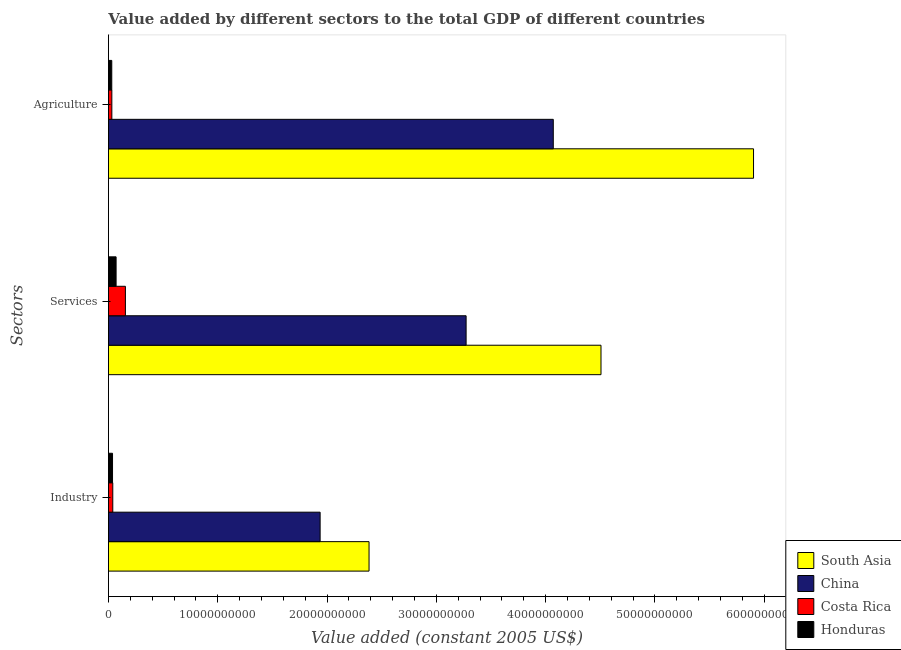How many different coloured bars are there?
Ensure brevity in your answer.  4. How many groups of bars are there?
Ensure brevity in your answer.  3. Are the number of bars on each tick of the Y-axis equal?
Offer a very short reply. Yes. How many bars are there on the 1st tick from the top?
Offer a terse response. 4. How many bars are there on the 1st tick from the bottom?
Make the answer very short. 4. What is the label of the 2nd group of bars from the top?
Give a very brief answer. Services. What is the value added by agricultural sector in Honduras?
Offer a very short reply. 3.05e+08. Across all countries, what is the maximum value added by industrial sector?
Ensure brevity in your answer.  2.38e+1. Across all countries, what is the minimum value added by agricultural sector?
Your answer should be compact. 3.05e+08. In which country was the value added by industrial sector minimum?
Your response must be concise. Honduras. What is the total value added by services in the graph?
Keep it short and to the point. 8.00e+1. What is the difference between the value added by services in China and that in Costa Rica?
Make the answer very short. 3.12e+1. What is the difference between the value added by services in South Asia and the value added by industrial sector in Costa Rica?
Your answer should be compact. 4.47e+1. What is the average value added by services per country?
Offer a very short reply. 2.00e+1. What is the difference between the value added by services and value added by agricultural sector in South Asia?
Keep it short and to the point. -1.40e+1. What is the ratio of the value added by services in Honduras to that in Costa Rica?
Offer a terse response. 0.45. What is the difference between the highest and the second highest value added by industrial sector?
Provide a succinct answer. 4.47e+09. What is the difference between the highest and the lowest value added by services?
Offer a very short reply. 4.44e+1. In how many countries, is the value added by industrial sector greater than the average value added by industrial sector taken over all countries?
Your answer should be compact. 2. What does the 1st bar from the top in Services represents?
Make the answer very short. Honduras. What does the 2nd bar from the bottom in Industry represents?
Your response must be concise. China. Is it the case that in every country, the sum of the value added by industrial sector and value added by services is greater than the value added by agricultural sector?
Your response must be concise. Yes. How many bars are there?
Offer a very short reply. 12. How many countries are there in the graph?
Your response must be concise. 4. How are the legend labels stacked?
Ensure brevity in your answer.  Vertical. What is the title of the graph?
Your response must be concise. Value added by different sectors to the total GDP of different countries. What is the label or title of the X-axis?
Give a very brief answer. Value added (constant 2005 US$). What is the label or title of the Y-axis?
Give a very brief answer. Sectors. What is the Value added (constant 2005 US$) of South Asia in Industry?
Your response must be concise. 2.38e+1. What is the Value added (constant 2005 US$) of China in Industry?
Offer a very short reply. 1.94e+1. What is the Value added (constant 2005 US$) in Costa Rica in Industry?
Offer a terse response. 3.98e+08. What is the Value added (constant 2005 US$) of Honduras in Industry?
Offer a terse response. 3.75e+08. What is the Value added (constant 2005 US$) in South Asia in Services?
Provide a short and direct response. 4.51e+1. What is the Value added (constant 2005 US$) in China in Services?
Offer a very short reply. 3.27e+1. What is the Value added (constant 2005 US$) in Costa Rica in Services?
Give a very brief answer. 1.55e+09. What is the Value added (constant 2005 US$) of Honduras in Services?
Provide a succinct answer. 7.01e+08. What is the Value added (constant 2005 US$) of South Asia in Agriculture?
Keep it short and to the point. 5.90e+1. What is the Value added (constant 2005 US$) of China in Agriculture?
Offer a very short reply. 4.07e+1. What is the Value added (constant 2005 US$) in Costa Rica in Agriculture?
Make the answer very short. 3.13e+08. What is the Value added (constant 2005 US$) of Honduras in Agriculture?
Make the answer very short. 3.05e+08. Across all Sectors, what is the maximum Value added (constant 2005 US$) in South Asia?
Offer a terse response. 5.90e+1. Across all Sectors, what is the maximum Value added (constant 2005 US$) in China?
Make the answer very short. 4.07e+1. Across all Sectors, what is the maximum Value added (constant 2005 US$) of Costa Rica?
Offer a terse response. 1.55e+09. Across all Sectors, what is the maximum Value added (constant 2005 US$) in Honduras?
Your answer should be compact. 7.01e+08. Across all Sectors, what is the minimum Value added (constant 2005 US$) of South Asia?
Ensure brevity in your answer.  2.38e+1. Across all Sectors, what is the minimum Value added (constant 2005 US$) in China?
Your response must be concise. 1.94e+1. Across all Sectors, what is the minimum Value added (constant 2005 US$) in Costa Rica?
Ensure brevity in your answer.  3.13e+08. Across all Sectors, what is the minimum Value added (constant 2005 US$) in Honduras?
Provide a short and direct response. 3.05e+08. What is the total Value added (constant 2005 US$) of South Asia in the graph?
Make the answer very short. 1.28e+11. What is the total Value added (constant 2005 US$) in China in the graph?
Your answer should be compact. 9.28e+1. What is the total Value added (constant 2005 US$) in Costa Rica in the graph?
Your answer should be very brief. 2.26e+09. What is the total Value added (constant 2005 US$) in Honduras in the graph?
Make the answer very short. 1.38e+09. What is the difference between the Value added (constant 2005 US$) in South Asia in Industry and that in Services?
Offer a terse response. -2.12e+1. What is the difference between the Value added (constant 2005 US$) of China in Industry and that in Services?
Your answer should be compact. -1.34e+1. What is the difference between the Value added (constant 2005 US$) in Costa Rica in Industry and that in Services?
Offer a terse response. -1.15e+09. What is the difference between the Value added (constant 2005 US$) of Honduras in Industry and that in Services?
Provide a succinct answer. -3.26e+08. What is the difference between the Value added (constant 2005 US$) of South Asia in Industry and that in Agriculture?
Your answer should be compact. -3.52e+1. What is the difference between the Value added (constant 2005 US$) of China in Industry and that in Agriculture?
Provide a short and direct response. -2.13e+1. What is the difference between the Value added (constant 2005 US$) of Costa Rica in Industry and that in Agriculture?
Your response must be concise. 8.48e+07. What is the difference between the Value added (constant 2005 US$) of Honduras in Industry and that in Agriculture?
Give a very brief answer. 6.98e+07. What is the difference between the Value added (constant 2005 US$) in South Asia in Services and that in Agriculture?
Your answer should be very brief. -1.40e+1. What is the difference between the Value added (constant 2005 US$) of China in Services and that in Agriculture?
Provide a short and direct response. -7.98e+09. What is the difference between the Value added (constant 2005 US$) of Costa Rica in Services and that in Agriculture?
Offer a terse response. 1.24e+09. What is the difference between the Value added (constant 2005 US$) of Honduras in Services and that in Agriculture?
Your answer should be compact. 3.96e+08. What is the difference between the Value added (constant 2005 US$) of South Asia in Industry and the Value added (constant 2005 US$) of China in Services?
Keep it short and to the point. -8.88e+09. What is the difference between the Value added (constant 2005 US$) in South Asia in Industry and the Value added (constant 2005 US$) in Costa Rica in Services?
Your response must be concise. 2.23e+1. What is the difference between the Value added (constant 2005 US$) of South Asia in Industry and the Value added (constant 2005 US$) of Honduras in Services?
Ensure brevity in your answer.  2.31e+1. What is the difference between the Value added (constant 2005 US$) of China in Industry and the Value added (constant 2005 US$) of Costa Rica in Services?
Ensure brevity in your answer.  1.78e+1. What is the difference between the Value added (constant 2005 US$) of China in Industry and the Value added (constant 2005 US$) of Honduras in Services?
Give a very brief answer. 1.87e+1. What is the difference between the Value added (constant 2005 US$) in Costa Rica in Industry and the Value added (constant 2005 US$) in Honduras in Services?
Provide a short and direct response. -3.03e+08. What is the difference between the Value added (constant 2005 US$) of South Asia in Industry and the Value added (constant 2005 US$) of China in Agriculture?
Offer a very short reply. -1.69e+1. What is the difference between the Value added (constant 2005 US$) of South Asia in Industry and the Value added (constant 2005 US$) of Costa Rica in Agriculture?
Your answer should be very brief. 2.35e+1. What is the difference between the Value added (constant 2005 US$) of South Asia in Industry and the Value added (constant 2005 US$) of Honduras in Agriculture?
Your response must be concise. 2.35e+1. What is the difference between the Value added (constant 2005 US$) in China in Industry and the Value added (constant 2005 US$) in Costa Rica in Agriculture?
Your answer should be very brief. 1.91e+1. What is the difference between the Value added (constant 2005 US$) in China in Industry and the Value added (constant 2005 US$) in Honduras in Agriculture?
Your answer should be very brief. 1.91e+1. What is the difference between the Value added (constant 2005 US$) of Costa Rica in Industry and the Value added (constant 2005 US$) of Honduras in Agriculture?
Offer a terse response. 9.24e+07. What is the difference between the Value added (constant 2005 US$) in South Asia in Services and the Value added (constant 2005 US$) in China in Agriculture?
Offer a terse response. 4.37e+09. What is the difference between the Value added (constant 2005 US$) in South Asia in Services and the Value added (constant 2005 US$) in Costa Rica in Agriculture?
Provide a short and direct response. 4.48e+1. What is the difference between the Value added (constant 2005 US$) of South Asia in Services and the Value added (constant 2005 US$) of Honduras in Agriculture?
Provide a short and direct response. 4.48e+1. What is the difference between the Value added (constant 2005 US$) of China in Services and the Value added (constant 2005 US$) of Costa Rica in Agriculture?
Ensure brevity in your answer.  3.24e+1. What is the difference between the Value added (constant 2005 US$) of China in Services and the Value added (constant 2005 US$) of Honduras in Agriculture?
Ensure brevity in your answer.  3.24e+1. What is the difference between the Value added (constant 2005 US$) in Costa Rica in Services and the Value added (constant 2005 US$) in Honduras in Agriculture?
Give a very brief answer. 1.25e+09. What is the average Value added (constant 2005 US$) of South Asia per Sectors?
Provide a succinct answer. 4.26e+1. What is the average Value added (constant 2005 US$) in China per Sectors?
Keep it short and to the point. 3.09e+1. What is the average Value added (constant 2005 US$) of Costa Rica per Sectors?
Offer a terse response. 7.54e+08. What is the average Value added (constant 2005 US$) in Honduras per Sectors?
Offer a very short reply. 4.61e+08. What is the difference between the Value added (constant 2005 US$) of South Asia and Value added (constant 2005 US$) of China in Industry?
Ensure brevity in your answer.  4.47e+09. What is the difference between the Value added (constant 2005 US$) in South Asia and Value added (constant 2005 US$) in Costa Rica in Industry?
Provide a succinct answer. 2.34e+1. What is the difference between the Value added (constant 2005 US$) in South Asia and Value added (constant 2005 US$) in Honduras in Industry?
Ensure brevity in your answer.  2.35e+1. What is the difference between the Value added (constant 2005 US$) in China and Value added (constant 2005 US$) in Costa Rica in Industry?
Offer a terse response. 1.90e+1. What is the difference between the Value added (constant 2005 US$) of China and Value added (constant 2005 US$) of Honduras in Industry?
Make the answer very short. 1.90e+1. What is the difference between the Value added (constant 2005 US$) of Costa Rica and Value added (constant 2005 US$) of Honduras in Industry?
Make the answer very short. 2.26e+07. What is the difference between the Value added (constant 2005 US$) of South Asia and Value added (constant 2005 US$) of China in Services?
Your answer should be compact. 1.23e+1. What is the difference between the Value added (constant 2005 US$) in South Asia and Value added (constant 2005 US$) in Costa Rica in Services?
Provide a succinct answer. 4.35e+1. What is the difference between the Value added (constant 2005 US$) of South Asia and Value added (constant 2005 US$) of Honduras in Services?
Provide a short and direct response. 4.44e+1. What is the difference between the Value added (constant 2005 US$) in China and Value added (constant 2005 US$) in Costa Rica in Services?
Provide a short and direct response. 3.12e+1. What is the difference between the Value added (constant 2005 US$) of China and Value added (constant 2005 US$) of Honduras in Services?
Keep it short and to the point. 3.20e+1. What is the difference between the Value added (constant 2005 US$) of Costa Rica and Value added (constant 2005 US$) of Honduras in Services?
Your response must be concise. 8.51e+08. What is the difference between the Value added (constant 2005 US$) in South Asia and Value added (constant 2005 US$) in China in Agriculture?
Make the answer very short. 1.83e+1. What is the difference between the Value added (constant 2005 US$) of South Asia and Value added (constant 2005 US$) of Costa Rica in Agriculture?
Ensure brevity in your answer.  5.87e+1. What is the difference between the Value added (constant 2005 US$) of South Asia and Value added (constant 2005 US$) of Honduras in Agriculture?
Your answer should be very brief. 5.87e+1. What is the difference between the Value added (constant 2005 US$) of China and Value added (constant 2005 US$) of Costa Rica in Agriculture?
Provide a succinct answer. 4.04e+1. What is the difference between the Value added (constant 2005 US$) of China and Value added (constant 2005 US$) of Honduras in Agriculture?
Give a very brief answer. 4.04e+1. What is the difference between the Value added (constant 2005 US$) in Costa Rica and Value added (constant 2005 US$) in Honduras in Agriculture?
Ensure brevity in your answer.  7.61e+06. What is the ratio of the Value added (constant 2005 US$) in South Asia in Industry to that in Services?
Your response must be concise. 0.53. What is the ratio of the Value added (constant 2005 US$) in China in Industry to that in Services?
Ensure brevity in your answer.  0.59. What is the ratio of the Value added (constant 2005 US$) of Costa Rica in Industry to that in Services?
Offer a very short reply. 0.26. What is the ratio of the Value added (constant 2005 US$) of Honduras in Industry to that in Services?
Provide a short and direct response. 0.54. What is the ratio of the Value added (constant 2005 US$) in South Asia in Industry to that in Agriculture?
Provide a short and direct response. 0.4. What is the ratio of the Value added (constant 2005 US$) of China in Industry to that in Agriculture?
Your answer should be very brief. 0.48. What is the ratio of the Value added (constant 2005 US$) of Costa Rica in Industry to that in Agriculture?
Provide a succinct answer. 1.27. What is the ratio of the Value added (constant 2005 US$) of Honduras in Industry to that in Agriculture?
Give a very brief answer. 1.23. What is the ratio of the Value added (constant 2005 US$) of South Asia in Services to that in Agriculture?
Give a very brief answer. 0.76. What is the ratio of the Value added (constant 2005 US$) of China in Services to that in Agriculture?
Make the answer very short. 0.8. What is the ratio of the Value added (constant 2005 US$) of Costa Rica in Services to that in Agriculture?
Provide a short and direct response. 4.96. What is the ratio of the Value added (constant 2005 US$) of Honduras in Services to that in Agriculture?
Offer a very short reply. 2.3. What is the difference between the highest and the second highest Value added (constant 2005 US$) in South Asia?
Provide a short and direct response. 1.40e+1. What is the difference between the highest and the second highest Value added (constant 2005 US$) in China?
Keep it short and to the point. 7.98e+09. What is the difference between the highest and the second highest Value added (constant 2005 US$) of Costa Rica?
Make the answer very short. 1.15e+09. What is the difference between the highest and the second highest Value added (constant 2005 US$) of Honduras?
Provide a succinct answer. 3.26e+08. What is the difference between the highest and the lowest Value added (constant 2005 US$) of South Asia?
Your answer should be compact. 3.52e+1. What is the difference between the highest and the lowest Value added (constant 2005 US$) in China?
Your answer should be very brief. 2.13e+1. What is the difference between the highest and the lowest Value added (constant 2005 US$) in Costa Rica?
Ensure brevity in your answer.  1.24e+09. What is the difference between the highest and the lowest Value added (constant 2005 US$) of Honduras?
Your answer should be very brief. 3.96e+08. 